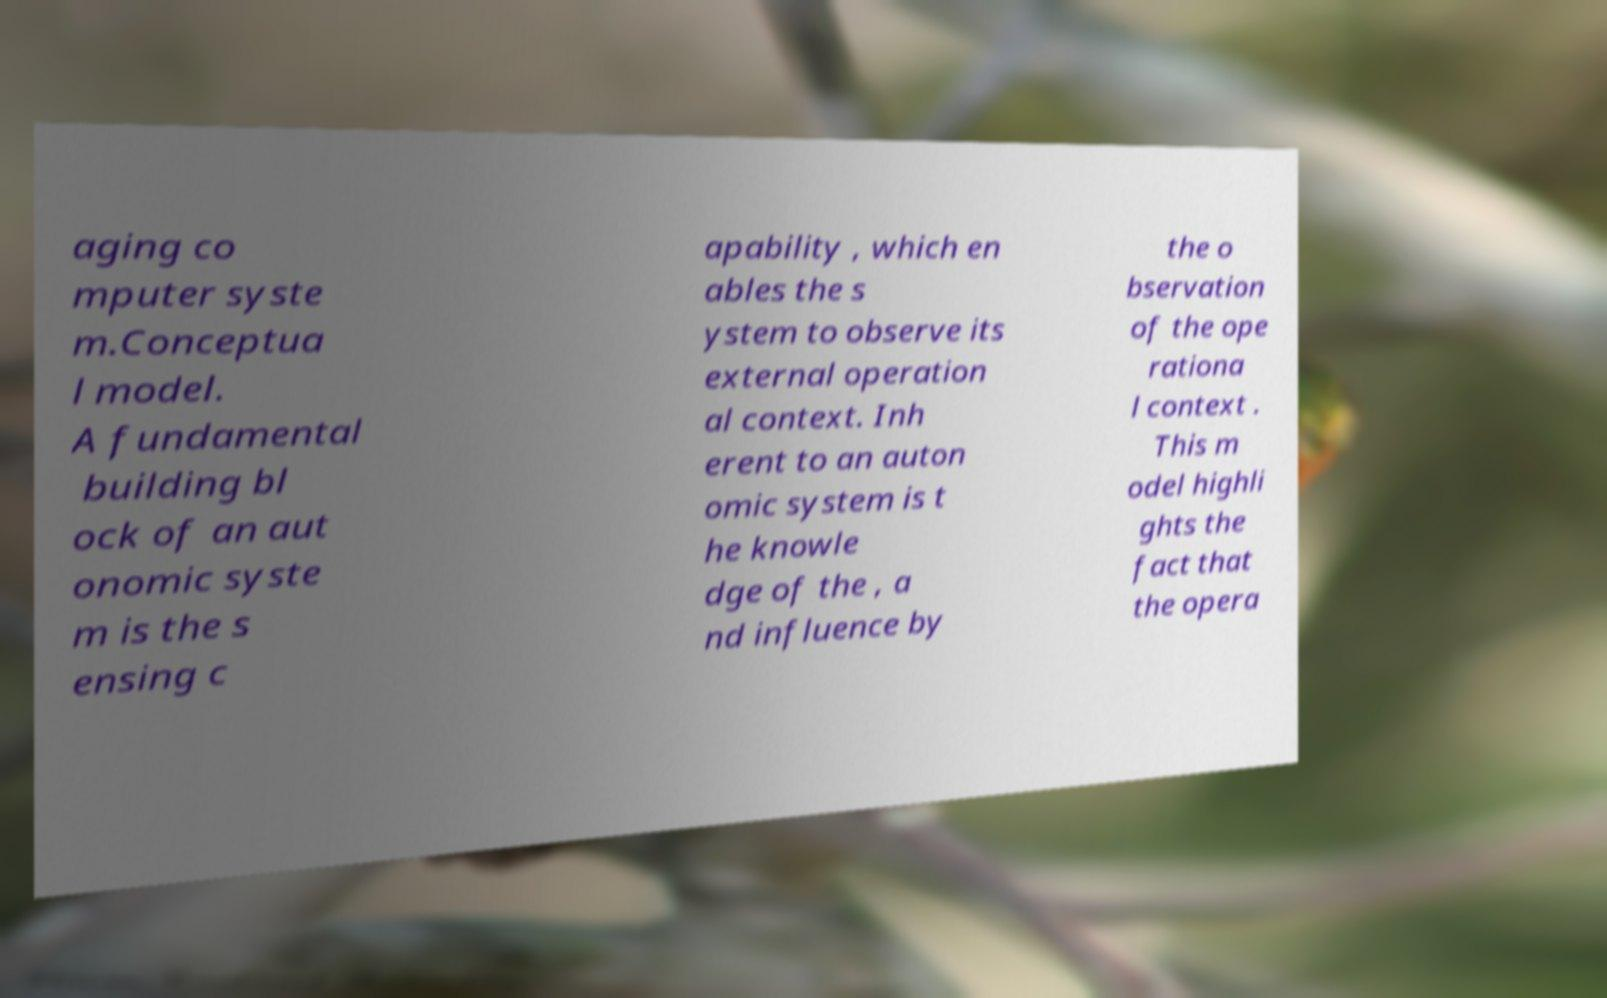What messages or text are displayed in this image? I need them in a readable, typed format. aging co mputer syste m.Conceptua l model. A fundamental building bl ock of an aut onomic syste m is the s ensing c apability , which en ables the s ystem to observe its external operation al context. Inh erent to an auton omic system is t he knowle dge of the , a nd influence by the o bservation of the ope rationa l context . This m odel highli ghts the fact that the opera 